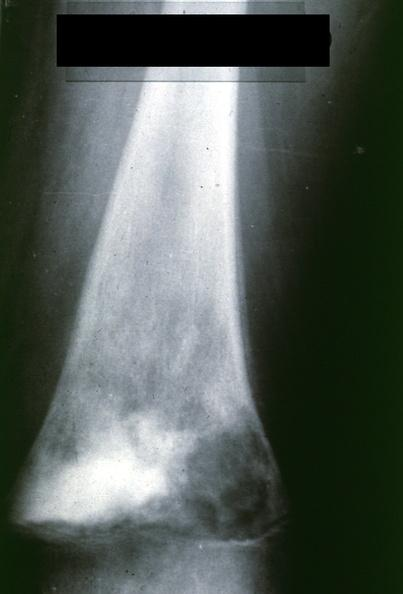s electron micrographs demonstrating fiber present?
Answer the question using a single word or phrase. No 